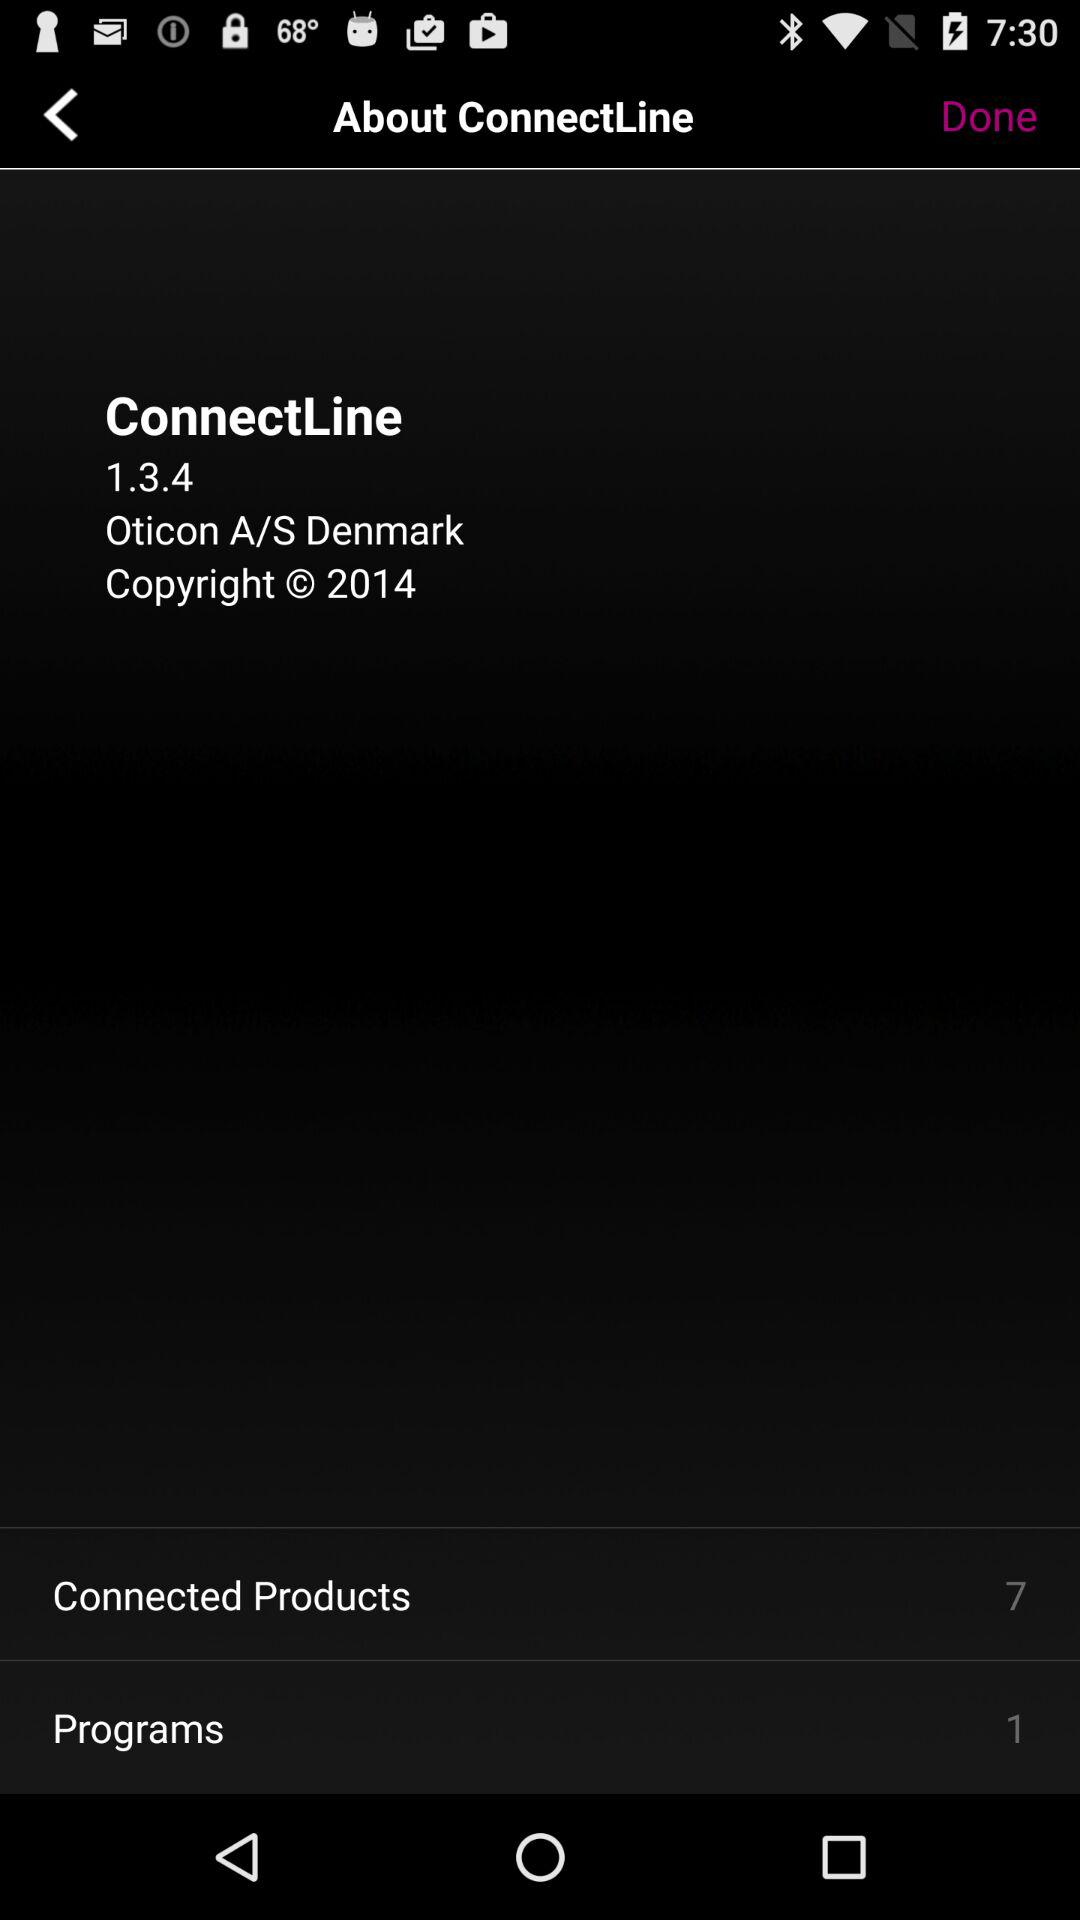What is the name of the application? The name of the application is "ConnectLine". 